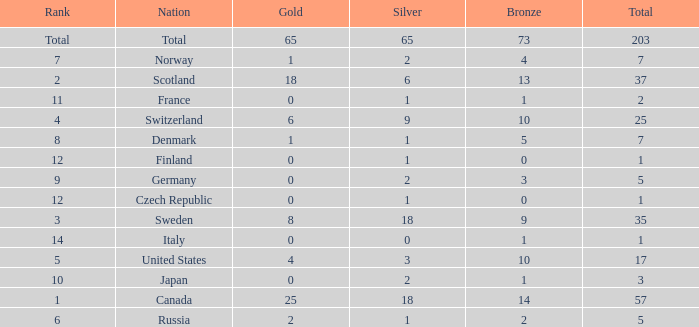What is the number of bronze medals when the total is greater than 1, more than 2 silver medals are won, and the rank is 2? 13.0. 